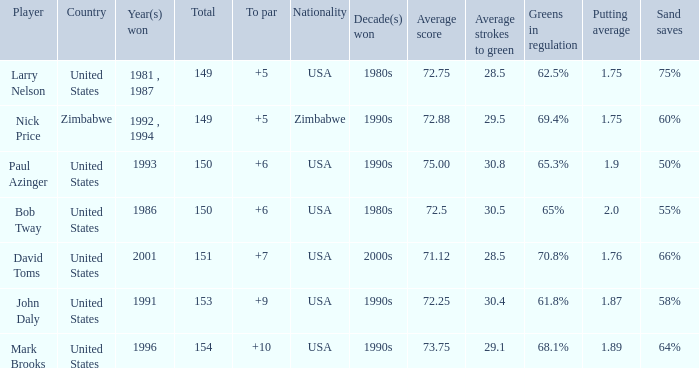Which player won in 1993? Paul Azinger. 